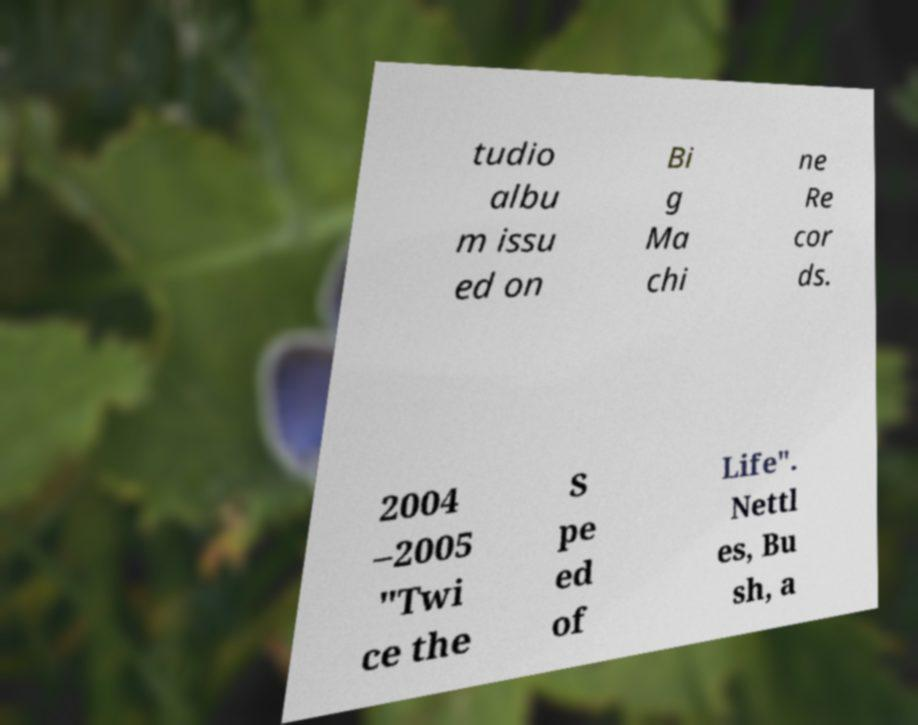What messages or text are displayed in this image? I need them in a readable, typed format. tudio albu m issu ed on Bi g Ma chi ne Re cor ds. 2004 –2005 "Twi ce the S pe ed of Life". Nettl es, Bu sh, a 